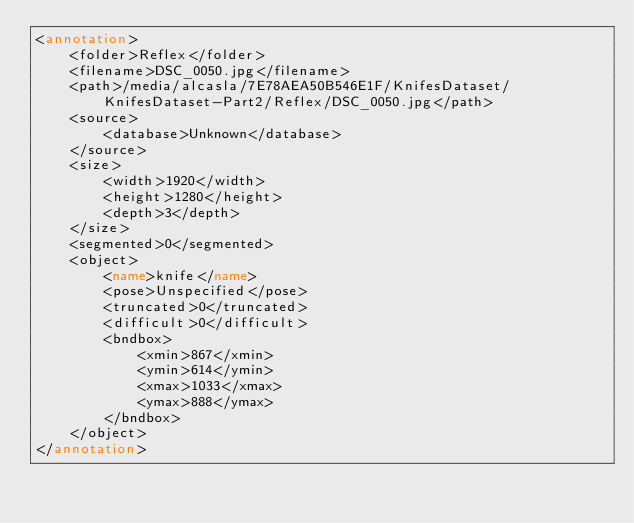<code> <loc_0><loc_0><loc_500><loc_500><_XML_><annotation>
	<folder>Reflex</folder>
	<filename>DSC_0050.jpg</filename>
	<path>/media/alcasla/7E78AEA50B546E1F/KnifesDataset/KnifesDataset-Part2/Reflex/DSC_0050.jpg</path>
	<source>
		<database>Unknown</database>
	</source>
	<size>
		<width>1920</width>
		<height>1280</height>
		<depth>3</depth>
	</size>
	<segmented>0</segmented>
	<object>
		<name>knife</name>
		<pose>Unspecified</pose>
		<truncated>0</truncated>
		<difficult>0</difficult>
		<bndbox>
			<xmin>867</xmin>
			<ymin>614</ymin>
			<xmax>1033</xmax>
			<ymax>888</ymax>
		</bndbox>
	</object>
</annotation>
</code> 